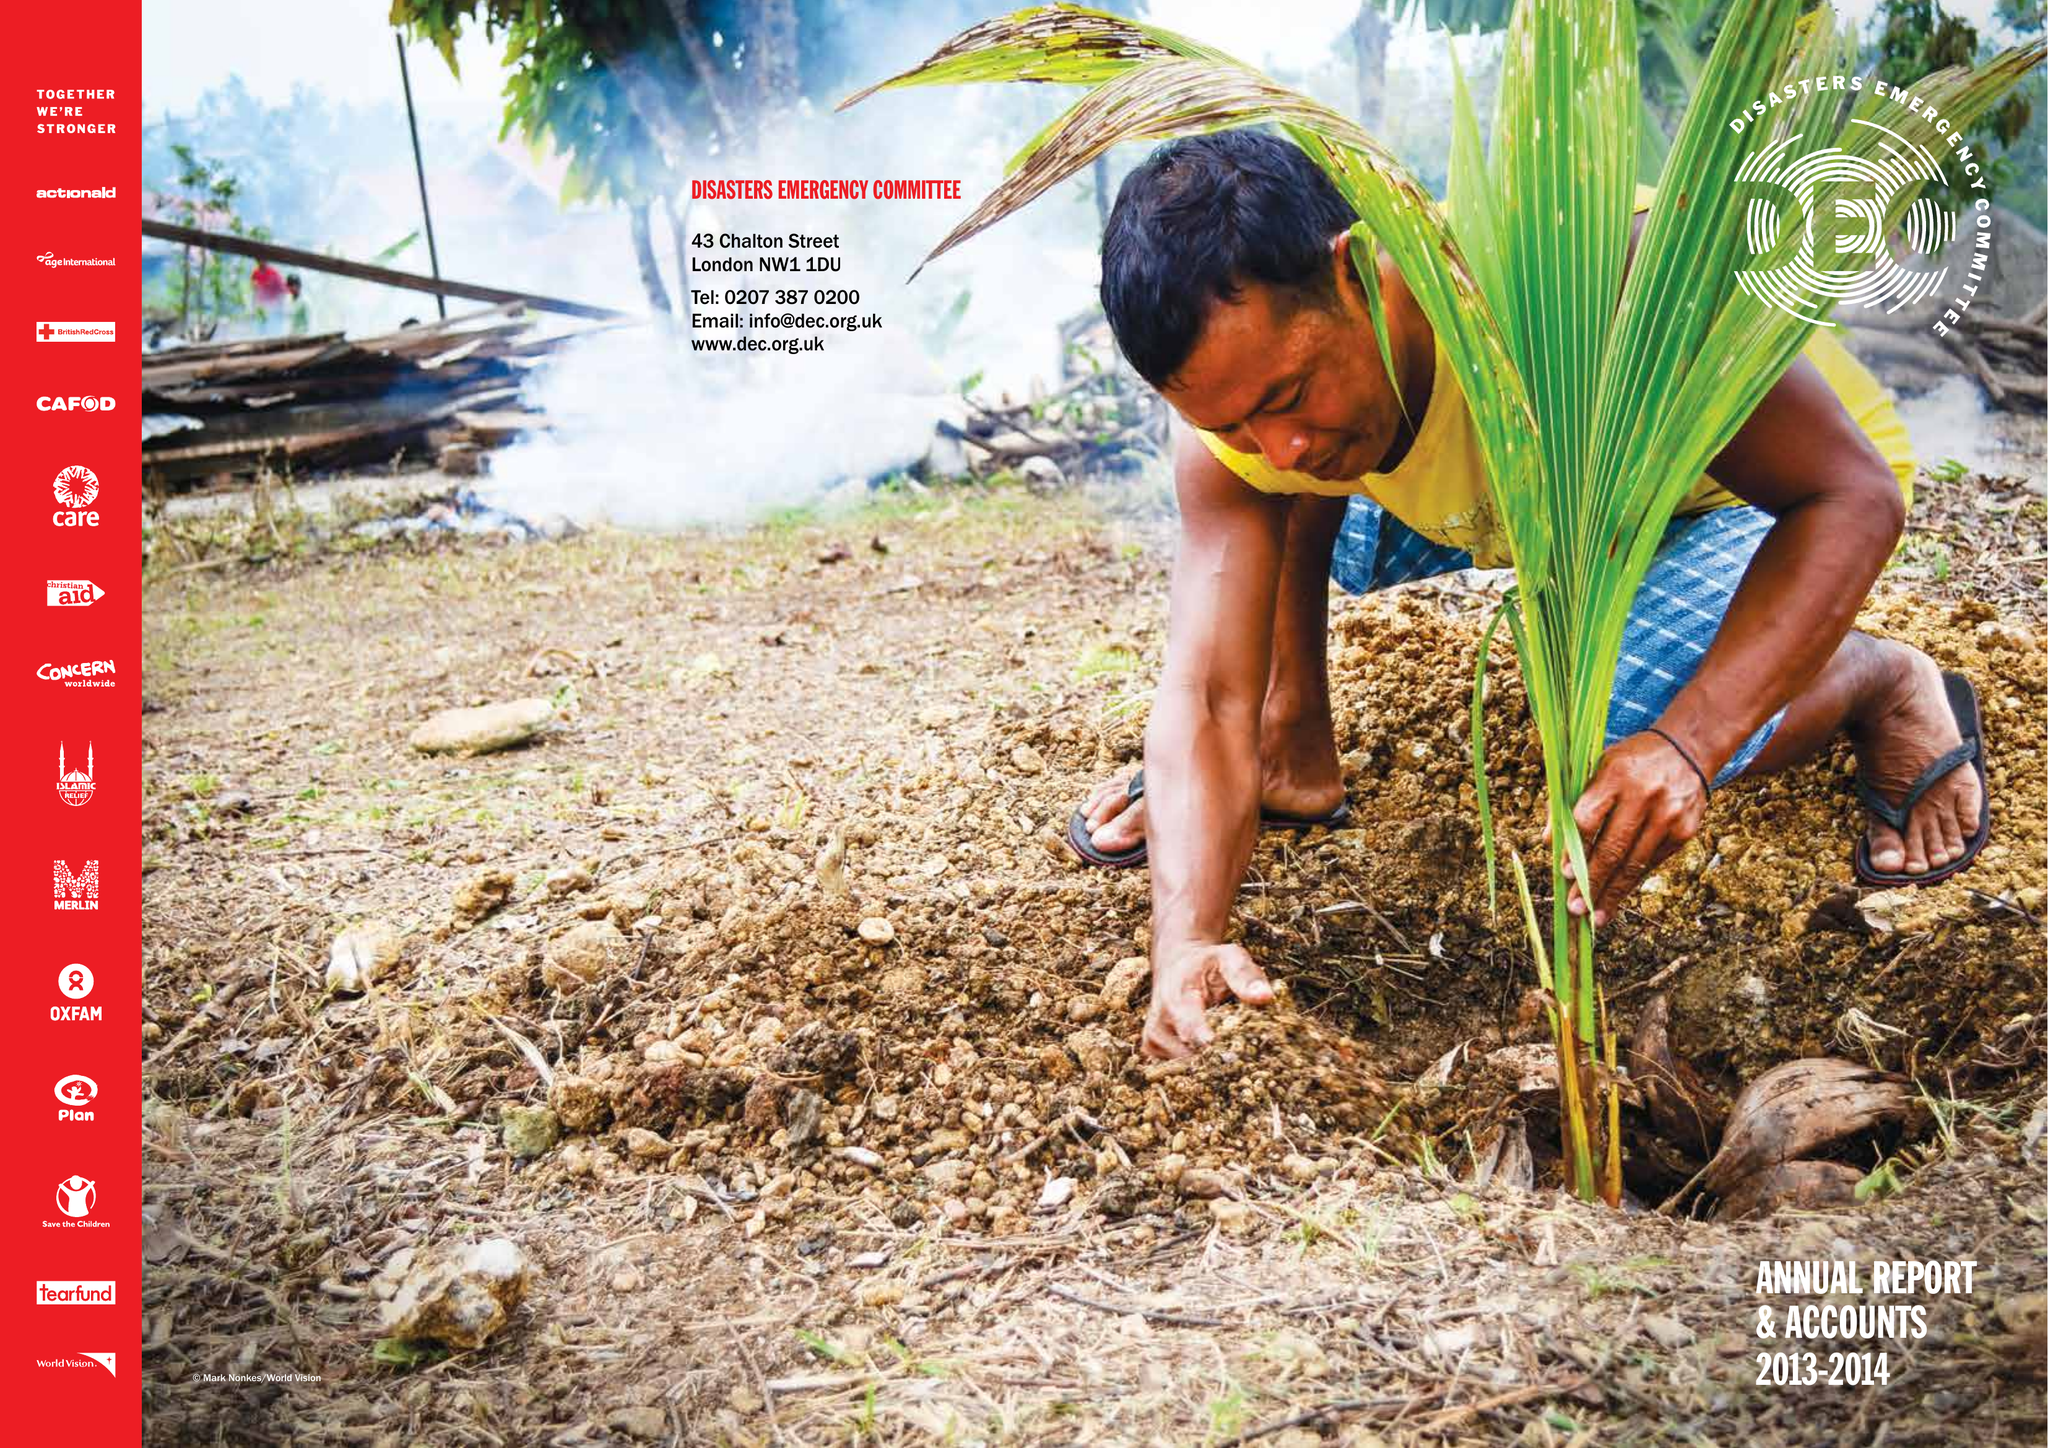What is the value for the charity_name?
Answer the question using a single word or phrase. Disasters Emergency Committee 